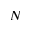Convert formula to latex. <formula><loc_0><loc_0><loc_500><loc_500>N</formula> 